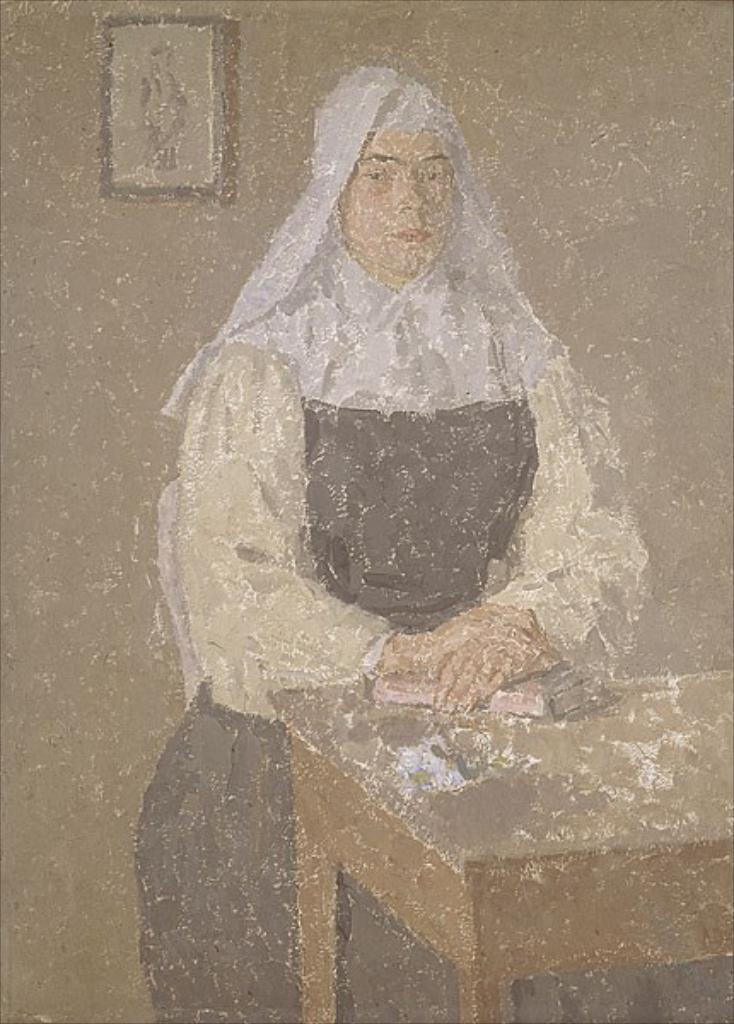Describe this image in one or two sentences. In this image there is a painting of a woman, in front of the woman there are books on the table, behind the woman there is a photo frame on the wall. 